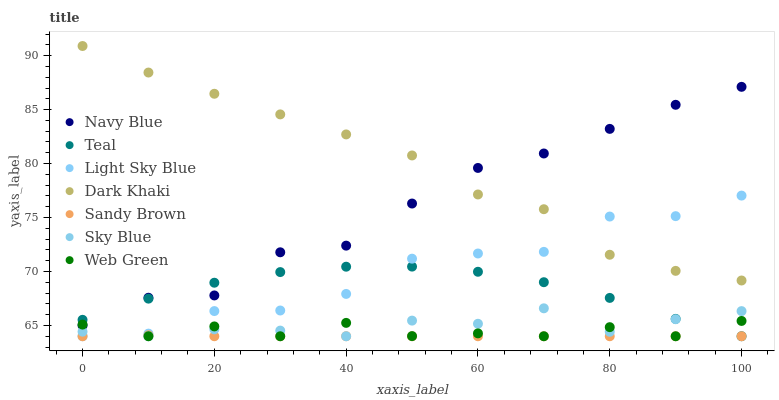Does Sandy Brown have the minimum area under the curve?
Answer yes or no. Yes. Does Dark Khaki have the maximum area under the curve?
Answer yes or no. Yes. Does Web Green have the minimum area under the curve?
Answer yes or no. No. Does Web Green have the maximum area under the curve?
Answer yes or no. No. Is Sandy Brown the smoothest?
Answer yes or no. Yes. Is Light Sky Blue the roughest?
Answer yes or no. Yes. Is Web Green the smoothest?
Answer yes or no. No. Is Web Green the roughest?
Answer yes or no. No. Does Web Green have the lowest value?
Answer yes or no. Yes. Does Dark Khaki have the lowest value?
Answer yes or no. No. Does Dark Khaki have the highest value?
Answer yes or no. Yes. Does Web Green have the highest value?
Answer yes or no. No. Is Teal less than Dark Khaki?
Answer yes or no. Yes. Is Navy Blue greater than Sky Blue?
Answer yes or no. Yes. Does Light Sky Blue intersect Web Green?
Answer yes or no. Yes. Is Light Sky Blue less than Web Green?
Answer yes or no. No. Is Light Sky Blue greater than Web Green?
Answer yes or no. No. Does Teal intersect Dark Khaki?
Answer yes or no. No. 